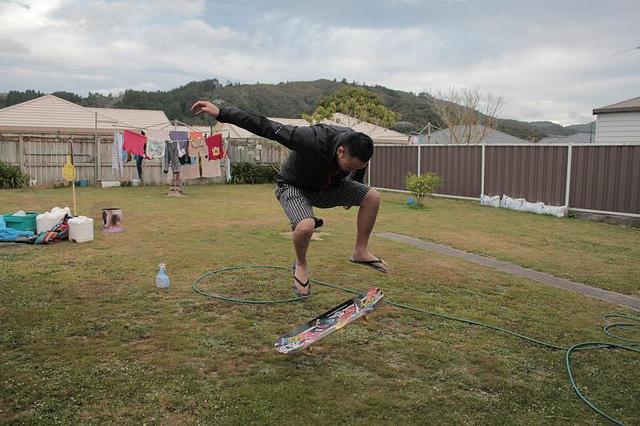What are these men wearing on their feet?
Write a very short answer. Flip flops. What is hung up?
Keep it brief. Clothes. What color is the hose?
Keep it brief. Green. What type of shoes is this man wearing?
Be succinct. Flip flops. 